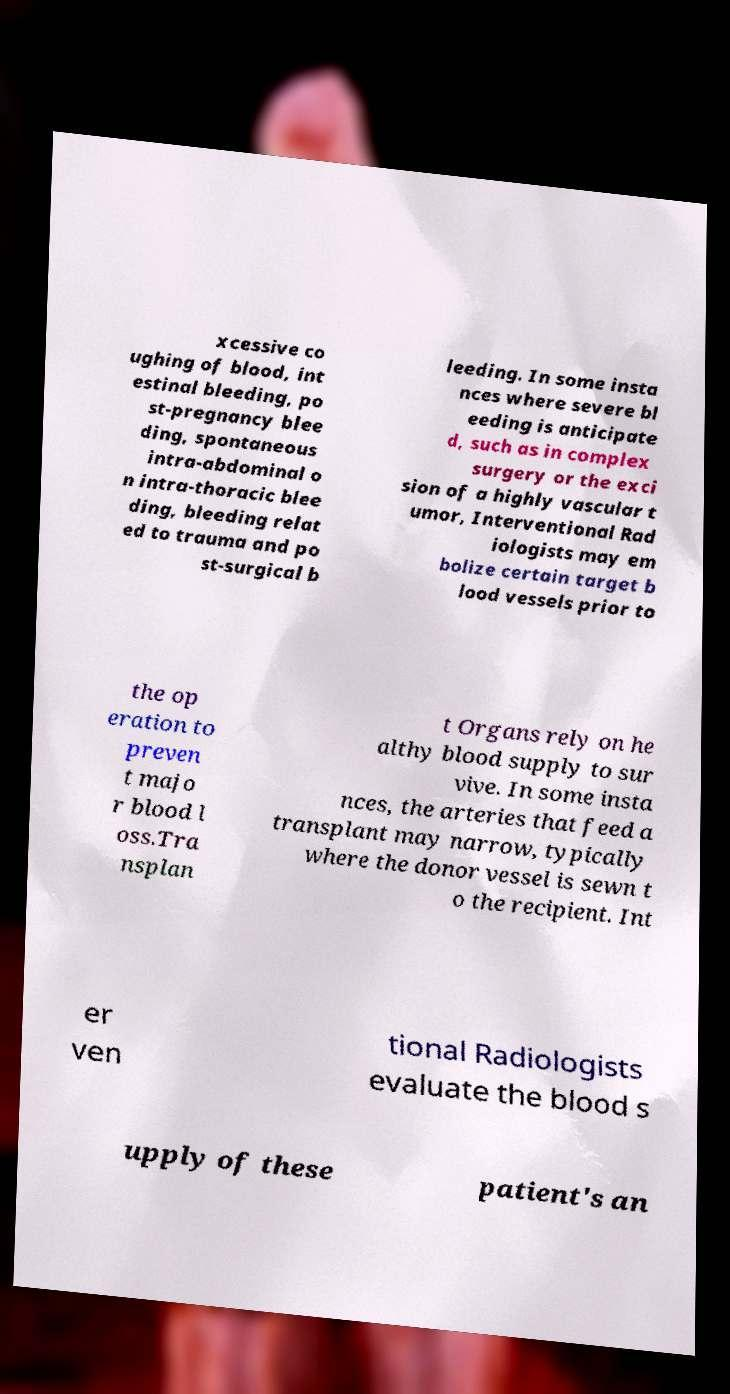I need the written content from this picture converted into text. Can you do that? xcessive co ughing of blood, int estinal bleeding, po st-pregnancy blee ding, spontaneous intra-abdominal o n intra-thoracic blee ding, bleeding relat ed to trauma and po st-surgical b leeding. In some insta nces where severe bl eeding is anticipate d, such as in complex surgery or the exci sion of a highly vascular t umor, Interventional Rad iologists may em bolize certain target b lood vessels prior to the op eration to preven t majo r blood l oss.Tra nsplan t Organs rely on he althy blood supply to sur vive. In some insta nces, the arteries that feed a transplant may narrow, typically where the donor vessel is sewn t o the recipient. Int er ven tional Radiologists evaluate the blood s upply of these patient's an 